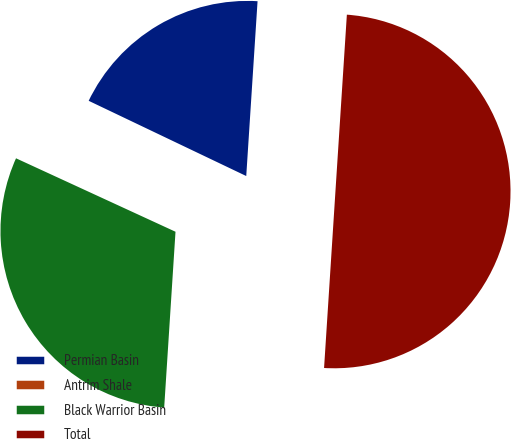Convert chart to OTSL. <chart><loc_0><loc_0><loc_500><loc_500><pie_chart><fcel>Permian Basin<fcel>Antrim Shale<fcel>Black Warrior Basin<fcel>Total<nl><fcel>18.97%<fcel>0.22%<fcel>30.82%<fcel>50.0%<nl></chart> 